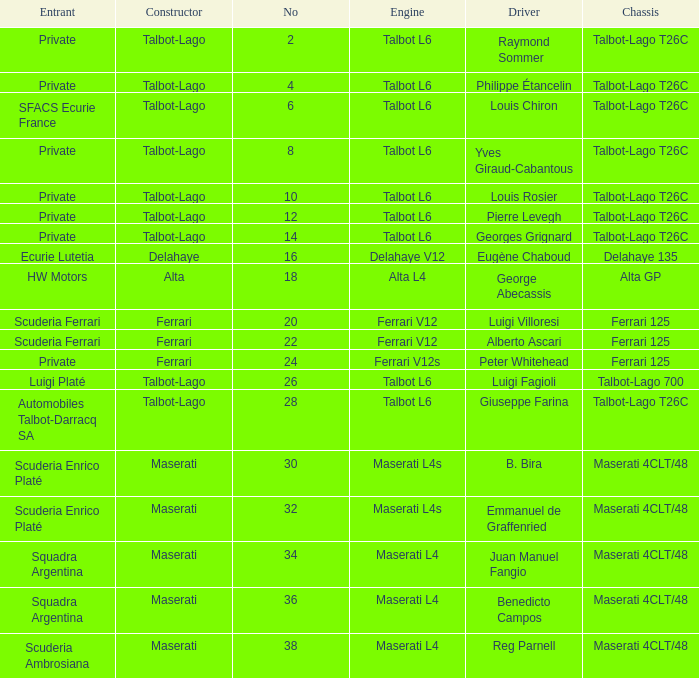Name the constructor for b. bira Maserati. 